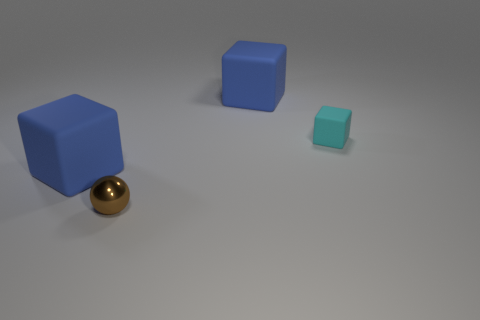Add 4 tiny yellow shiny objects. How many objects exist? 8 Subtract all cubes. How many objects are left? 1 Subtract all rubber blocks. Subtract all tiny cyan matte blocks. How many objects are left? 0 Add 3 blue rubber things. How many blue rubber things are left? 5 Add 3 big objects. How many big objects exist? 5 Subtract 0 yellow cylinders. How many objects are left? 4 